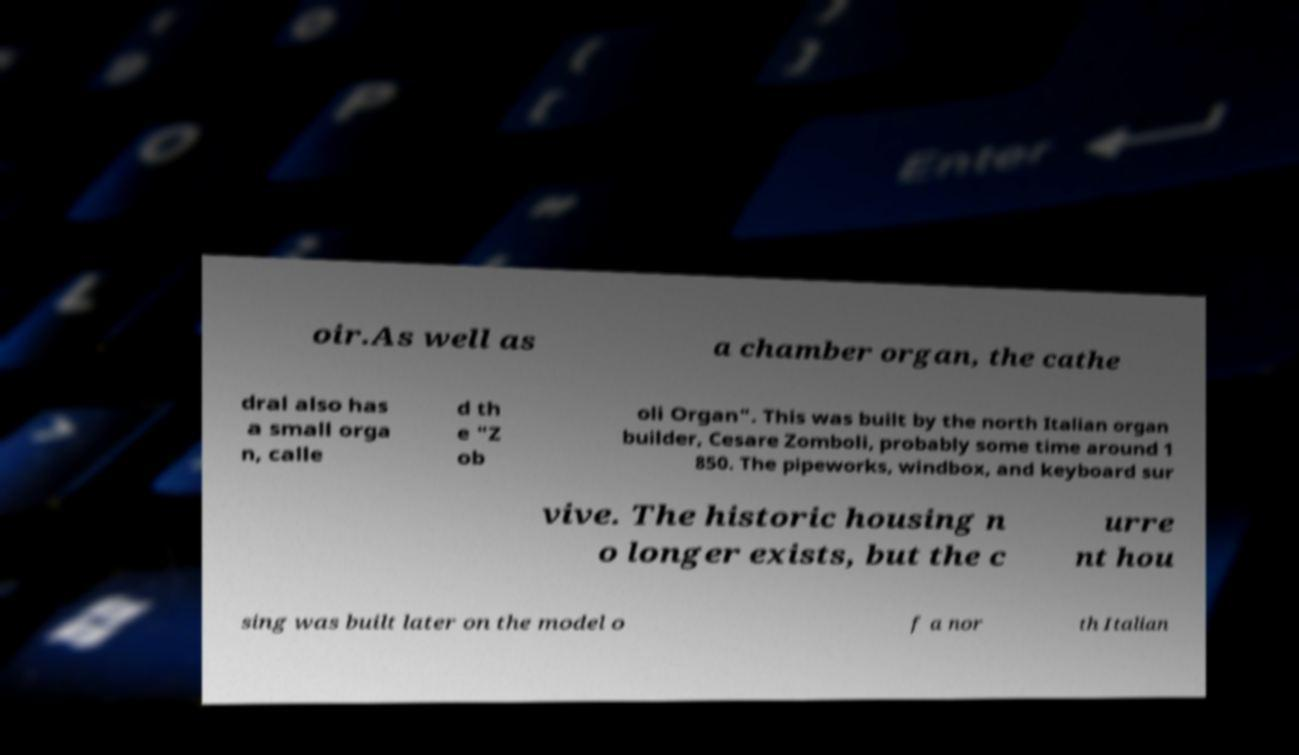For documentation purposes, I need the text within this image transcribed. Could you provide that? oir.As well as a chamber organ, the cathe dral also has a small orga n, calle d th e "Z ob oli Organ". This was built by the north Italian organ builder, Cesare Zomboli, probably some time around 1 850. The pipeworks, windbox, and keyboard sur vive. The historic housing n o longer exists, but the c urre nt hou sing was built later on the model o f a nor th Italian 